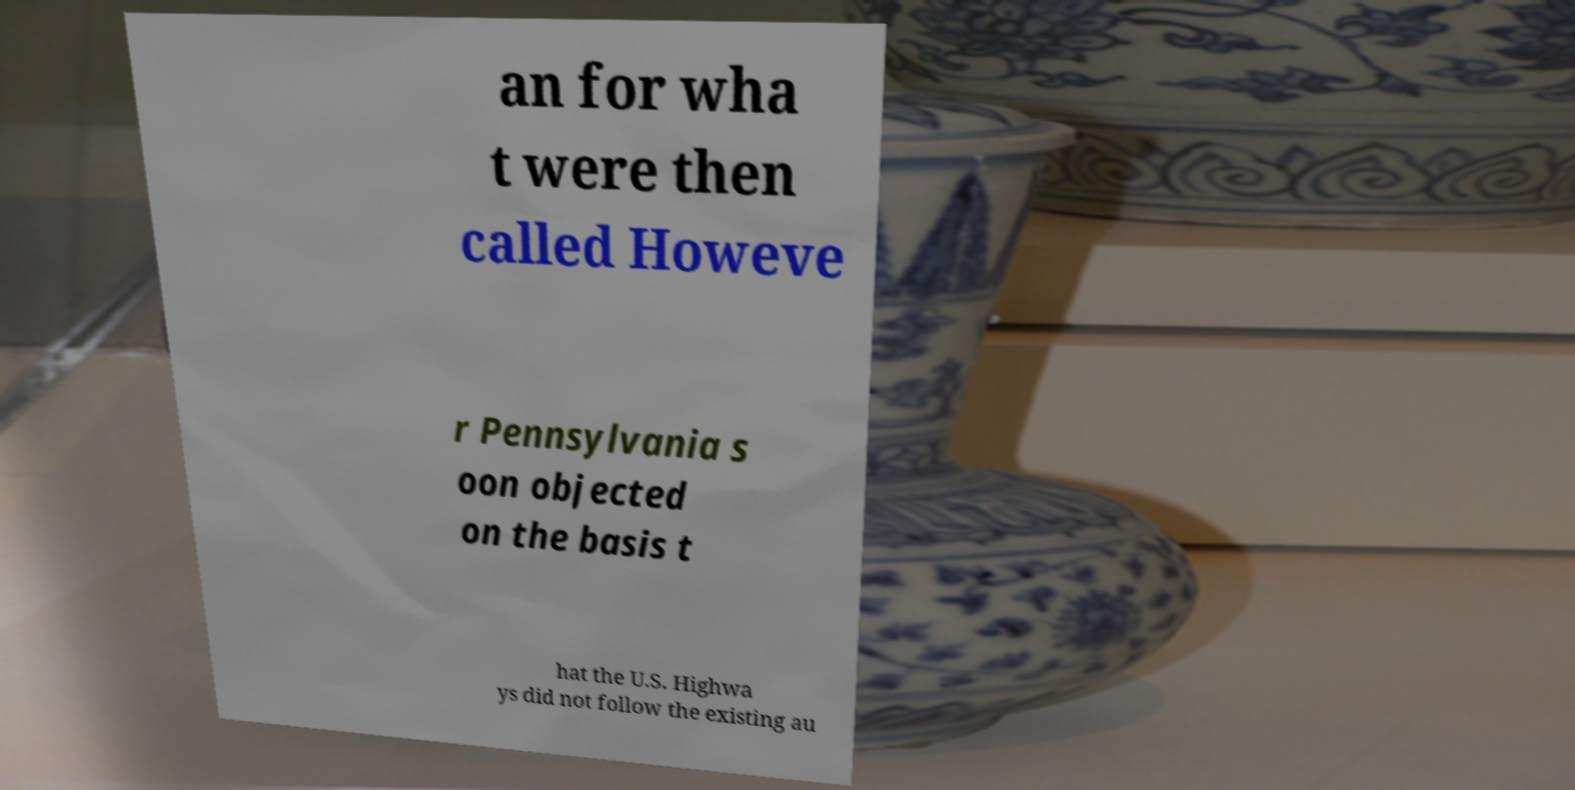Can you read and provide the text displayed in the image?This photo seems to have some interesting text. Can you extract and type it out for me? an for wha t were then called Howeve r Pennsylvania s oon objected on the basis t hat the U.S. Highwa ys did not follow the existing au 